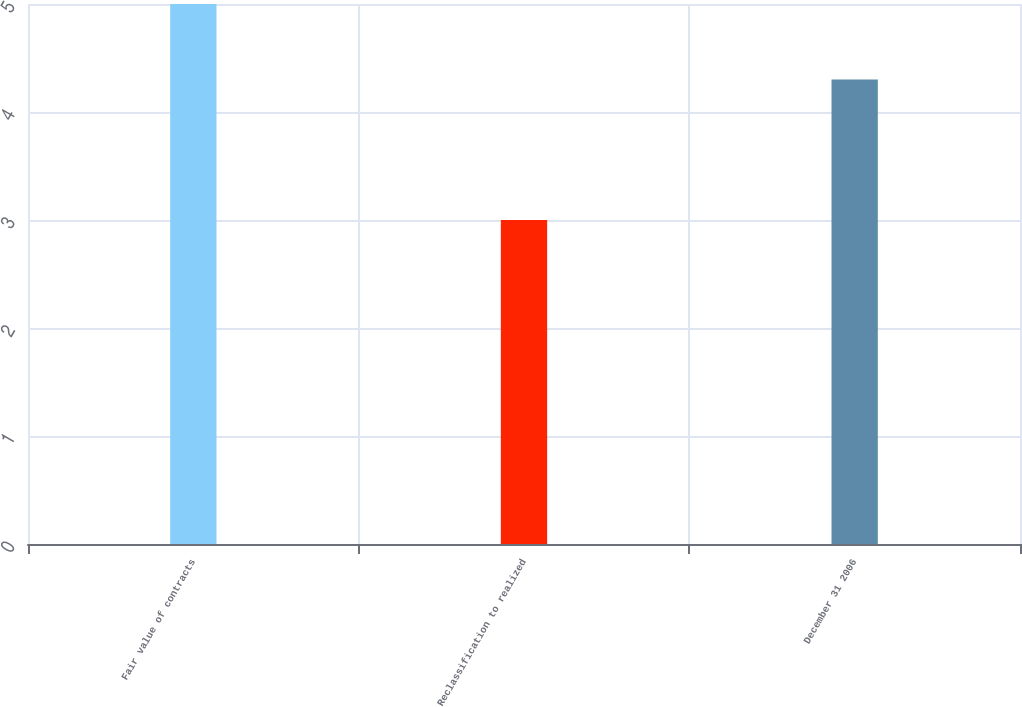<chart> <loc_0><loc_0><loc_500><loc_500><bar_chart><fcel>Fair value of contracts<fcel>Reclassification to realized<fcel>December 31 2006<nl><fcel>5<fcel>3<fcel>4.3<nl></chart> 